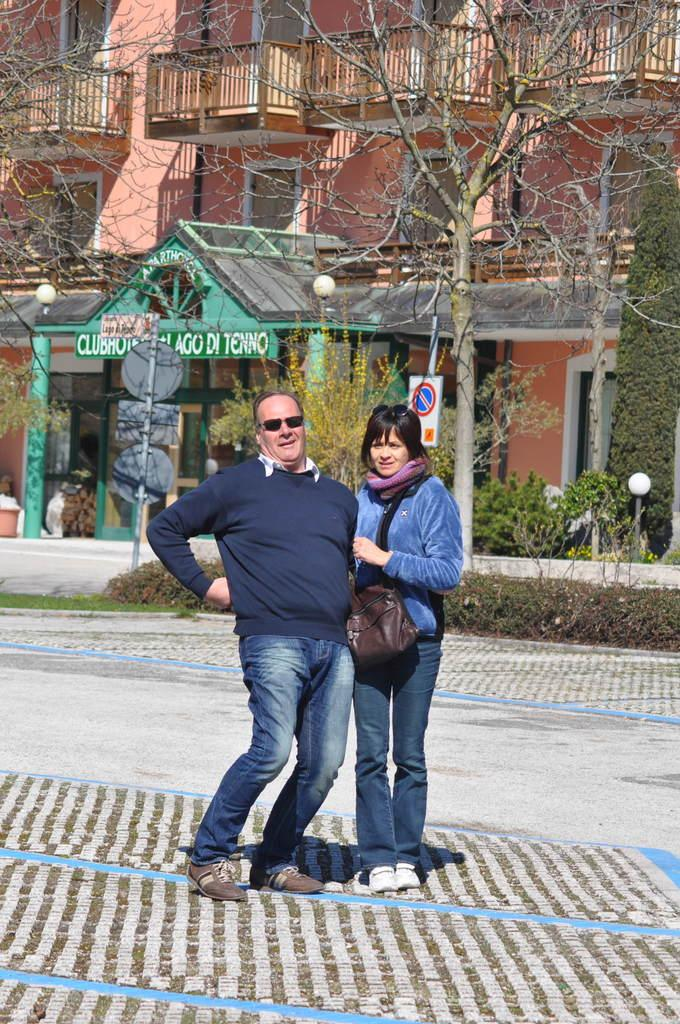How many people are present in the image? There are two people standing in the image. What is behind the people in the image? There are poles with boards behind the people. What can be seen in the background of the image? There are trees, plants, and a building in the background of the image. What type of coach can be seen in the image? There is no coach present in the image. Is there a jail visible in the image? There is no jail visible in the image. 